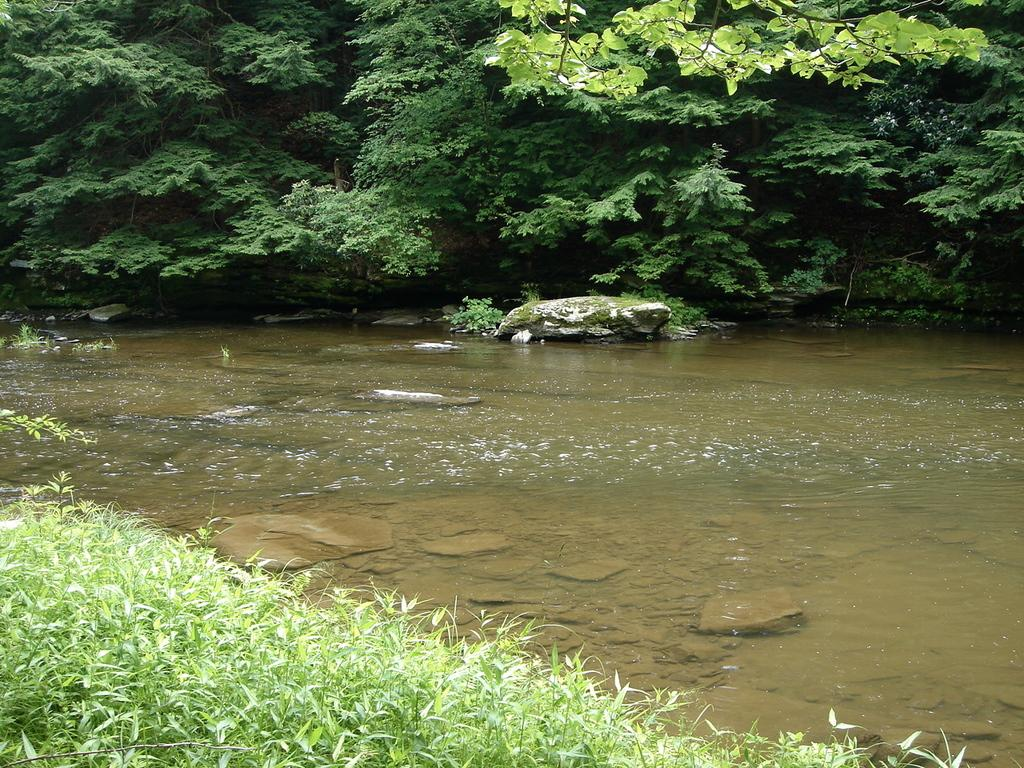What type of body of water is present in the image? There is a lake in the image. What type of vegetation is in front of the image? There is grass in front of the image. What type of natural feature can be seen in the background of the image? There are trees in the background of the image. What type of geological feature is present in the image? There are rocks in the image. Can you tell me how many grains of sand are on the rocks in the image? There is no sand present in the image; it features rocks in a lake setting. What type of bird is visible in the image? There are no birds visible in the image; it features a lake, grass, trees, and rocks. 